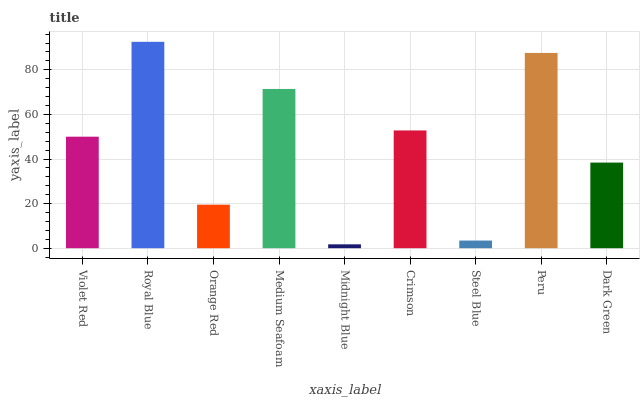Is Midnight Blue the minimum?
Answer yes or no. Yes. Is Royal Blue the maximum?
Answer yes or no. Yes. Is Orange Red the minimum?
Answer yes or no. No. Is Orange Red the maximum?
Answer yes or no. No. Is Royal Blue greater than Orange Red?
Answer yes or no. Yes. Is Orange Red less than Royal Blue?
Answer yes or no. Yes. Is Orange Red greater than Royal Blue?
Answer yes or no. No. Is Royal Blue less than Orange Red?
Answer yes or no. No. Is Violet Red the high median?
Answer yes or no. Yes. Is Violet Red the low median?
Answer yes or no. Yes. Is Peru the high median?
Answer yes or no. No. Is Medium Seafoam the low median?
Answer yes or no. No. 